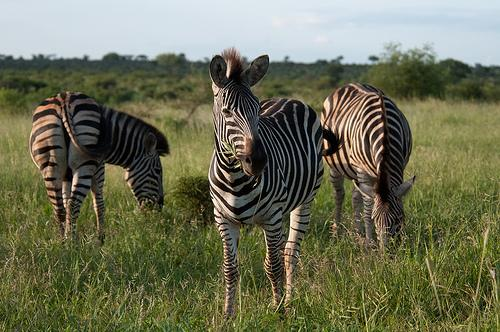What is the main focus of this image and what is unique about their appearance? The main focus is the zebras with unique black and white stripes eating grass in the field. Describe the setting of the image in terms of vegetation. The setting is a field with tall green grass, green bushy trees, and high grass. What is the condition of the sky in the background of the image? The blue sky is clear with clouds present. What is the sentiment or emotion evoked by the image? The image evokes a feeling of serenity and calmness in nature. What is the position and appearance of the zebra tails in the image? The tails are in rear view, with one on the left having a curved tail. What is the primary action taking place involving the zebras? The primary action is zebras eating grass and standing in the tall grass. Can you identify the colors present on the zebras in the image? The zebras have black and white stripes. Count the number of zebra legs visible in the image. There are three zebra legs visible in the image. Identify the state of the ears of the zebras in the image. The ears are standing up, displayed on zebras in left, middle, and right positions. How many zebras are present in the image and where are they standing? There are three zebras standing in a field with tall grass. 